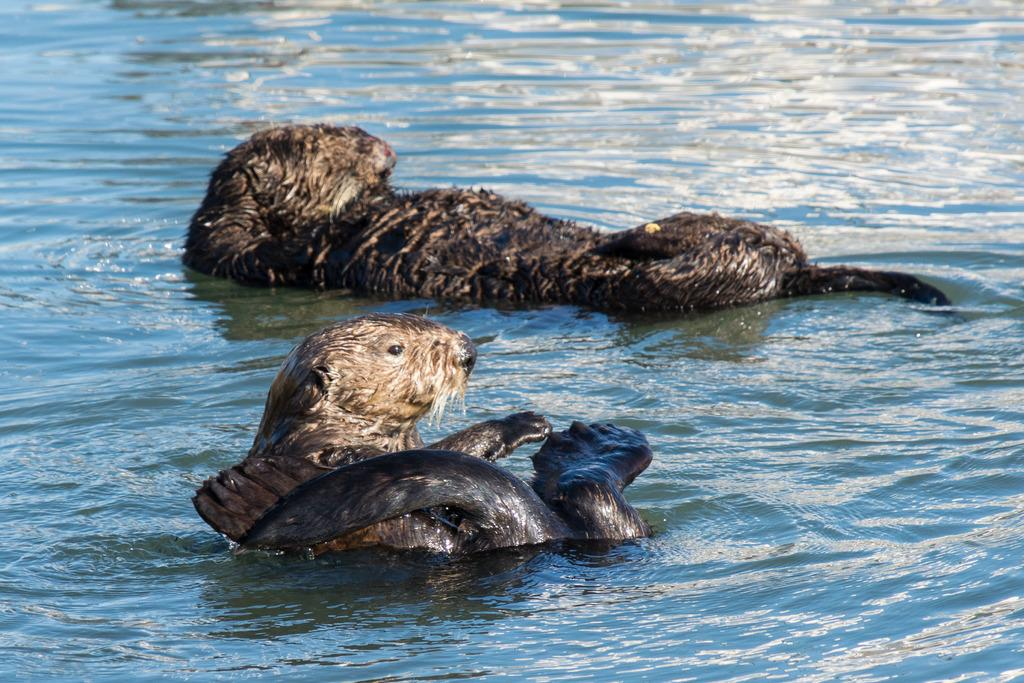What type of animals can be seen in the image? There are animals in the water in the image. What type of stove can be seen in the image? There is no stove present in the image; it features animals in the water. What things can be seen in the zoo in the image? There is no zoo present in the image; it features animals in the water. 